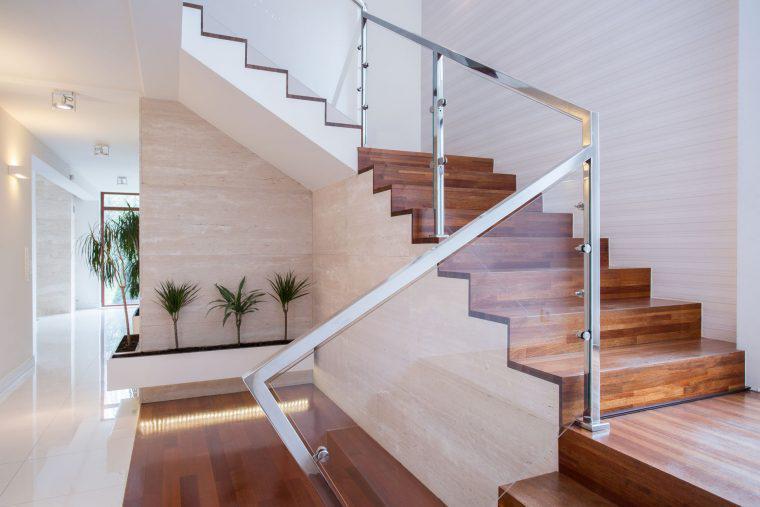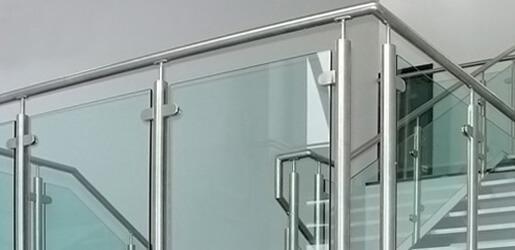The first image is the image on the left, the second image is the image on the right. Analyze the images presented: Is the assertion "One image shows a glass-paneled balcony in a white building, and the other shows a glass-paneled staircase railing next to brown wood steps." valid? Answer yes or no. Yes. The first image is the image on the left, the second image is the image on the right. For the images displayed, is the sentence "In one image the sky and clouds are visible." factually correct? Answer yes or no. No. 